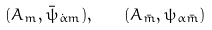<formula> <loc_0><loc_0><loc_500><loc_500>( A _ { m } , \bar { \psi } _ { \dot { \alpha } m } ) , \quad ( A _ { \bar { m } } , \psi _ { \alpha \bar { m } } )</formula> 